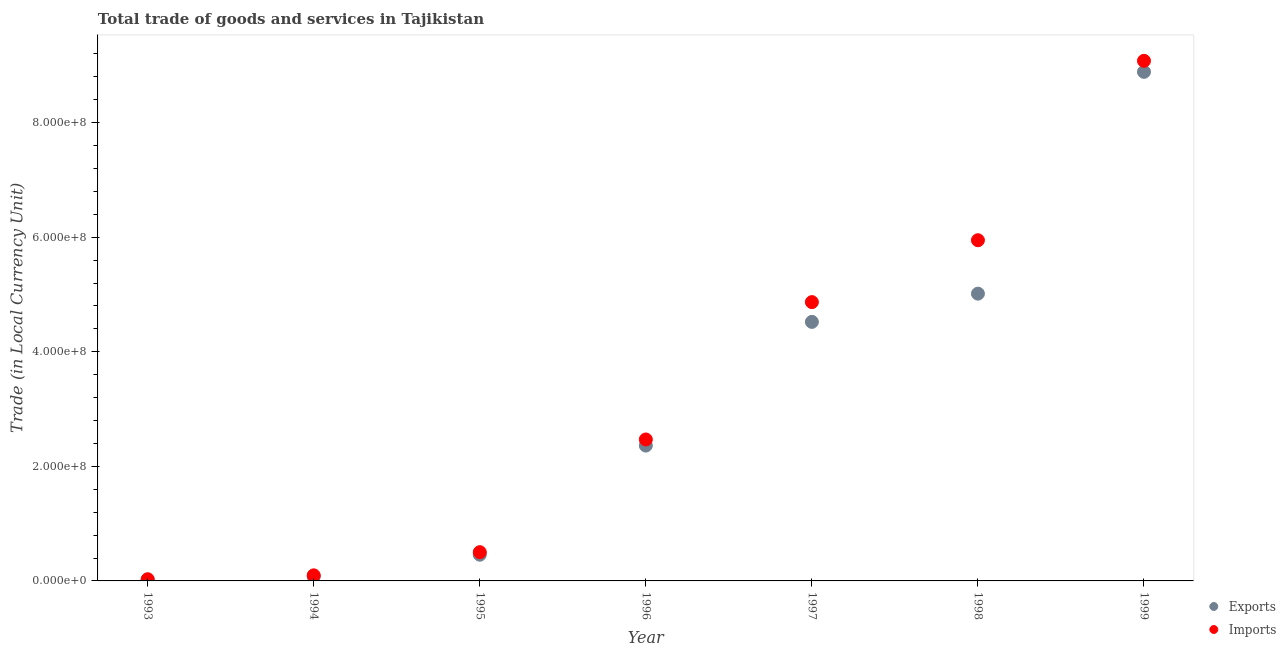How many different coloured dotlines are there?
Offer a terse response. 2. What is the imports of goods and services in 1994?
Offer a terse response. 9.76e+06. Across all years, what is the maximum imports of goods and services?
Your answer should be very brief. 9.08e+08. Across all years, what is the minimum export of goods and services?
Offer a terse response. 2.02e+06. In which year was the imports of goods and services maximum?
Make the answer very short. 1999. What is the total imports of goods and services in the graph?
Give a very brief answer. 2.30e+09. What is the difference between the imports of goods and services in 1995 and that in 1999?
Provide a succinct answer. -8.58e+08. What is the difference between the export of goods and services in 1994 and the imports of goods and services in 1995?
Your response must be concise. -4.25e+07. What is the average imports of goods and services per year?
Provide a succinct answer. 3.28e+08. In the year 1996, what is the difference between the export of goods and services and imports of goods and services?
Ensure brevity in your answer.  -1.07e+07. In how many years, is the imports of goods and services greater than 600000000 LCU?
Offer a very short reply. 1. What is the ratio of the imports of goods and services in 1996 to that in 1997?
Keep it short and to the point. 0.51. Is the export of goods and services in 1997 less than that in 1999?
Give a very brief answer. Yes. What is the difference between the highest and the second highest imports of goods and services?
Your response must be concise. 3.13e+08. What is the difference between the highest and the lowest imports of goods and services?
Keep it short and to the point. 9.05e+08. In how many years, is the export of goods and services greater than the average export of goods and services taken over all years?
Make the answer very short. 3. Does the export of goods and services monotonically increase over the years?
Offer a terse response. Yes. Is the imports of goods and services strictly less than the export of goods and services over the years?
Provide a short and direct response. No. How many dotlines are there?
Keep it short and to the point. 2. How many years are there in the graph?
Ensure brevity in your answer.  7. What is the difference between two consecutive major ticks on the Y-axis?
Keep it short and to the point. 2.00e+08. Are the values on the major ticks of Y-axis written in scientific E-notation?
Provide a short and direct response. Yes. Does the graph contain any zero values?
Offer a terse response. No. How are the legend labels stacked?
Your answer should be compact. Vertical. What is the title of the graph?
Your answer should be very brief. Total trade of goods and services in Tajikistan. What is the label or title of the X-axis?
Your answer should be compact. Year. What is the label or title of the Y-axis?
Keep it short and to the point. Trade (in Local Currency Unit). What is the Trade (in Local Currency Unit) in Exports in 1993?
Your response must be concise. 2.02e+06. What is the Trade (in Local Currency Unit) of Imports in 1993?
Your answer should be very brief. 2.94e+06. What is the Trade (in Local Currency Unit) in Exports in 1994?
Offer a very short reply. 7.69e+06. What is the Trade (in Local Currency Unit) of Imports in 1994?
Keep it short and to the point. 9.76e+06. What is the Trade (in Local Currency Unit) in Exports in 1995?
Provide a succinct answer. 4.58e+07. What is the Trade (in Local Currency Unit) in Imports in 1995?
Offer a terse response. 5.02e+07. What is the Trade (in Local Currency Unit) of Exports in 1996?
Your answer should be compact. 2.36e+08. What is the Trade (in Local Currency Unit) of Imports in 1996?
Keep it short and to the point. 2.47e+08. What is the Trade (in Local Currency Unit) in Exports in 1997?
Ensure brevity in your answer.  4.52e+08. What is the Trade (in Local Currency Unit) of Imports in 1997?
Provide a succinct answer. 4.87e+08. What is the Trade (in Local Currency Unit) in Exports in 1998?
Provide a succinct answer. 5.01e+08. What is the Trade (in Local Currency Unit) in Imports in 1998?
Provide a succinct answer. 5.95e+08. What is the Trade (in Local Currency Unit) of Exports in 1999?
Your answer should be compact. 8.89e+08. What is the Trade (in Local Currency Unit) in Imports in 1999?
Provide a short and direct response. 9.08e+08. Across all years, what is the maximum Trade (in Local Currency Unit) in Exports?
Give a very brief answer. 8.89e+08. Across all years, what is the maximum Trade (in Local Currency Unit) of Imports?
Provide a succinct answer. 9.08e+08. Across all years, what is the minimum Trade (in Local Currency Unit) of Exports?
Your response must be concise. 2.02e+06. Across all years, what is the minimum Trade (in Local Currency Unit) in Imports?
Give a very brief answer. 2.94e+06. What is the total Trade (in Local Currency Unit) in Exports in the graph?
Make the answer very short. 2.13e+09. What is the total Trade (in Local Currency Unit) in Imports in the graph?
Your response must be concise. 2.30e+09. What is the difference between the Trade (in Local Currency Unit) of Exports in 1993 and that in 1994?
Give a very brief answer. -5.67e+06. What is the difference between the Trade (in Local Currency Unit) in Imports in 1993 and that in 1994?
Your answer should be very brief. -6.81e+06. What is the difference between the Trade (in Local Currency Unit) in Exports in 1993 and that in 1995?
Your response must be concise. -4.38e+07. What is the difference between the Trade (in Local Currency Unit) in Imports in 1993 and that in 1995?
Give a very brief answer. -4.73e+07. What is the difference between the Trade (in Local Currency Unit) of Exports in 1993 and that in 1996?
Offer a terse response. -2.34e+08. What is the difference between the Trade (in Local Currency Unit) in Imports in 1993 and that in 1996?
Ensure brevity in your answer.  -2.44e+08. What is the difference between the Trade (in Local Currency Unit) in Exports in 1993 and that in 1997?
Provide a short and direct response. -4.50e+08. What is the difference between the Trade (in Local Currency Unit) of Imports in 1993 and that in 1997?
Your answer should be compact. -4.84e+08. What is the difference between the Trade (in Local Currency Unit) in Exports in 1993 and that in 1998?
Keep it short and to the point. -4.99e+08. What is the difference between the Trade (in Local Currency Unit) of Imports in 1993 and that in 1998?
Provide a succinct answer. -5.92e+08. What is the difference between the Trade (in Local Currency Unit) in Exports in 1993 and that in 1999?
Your answer should be very brief. -8.87e+08. What is the difference between the Trade (in Local Currency Unit) of Imports in 1993 and that in 1999?
Your answer should be very brief. -9.05e+08. What is the difference between the Trade (in Local Currency Unit) of Exports in 1994 and that in 1995?
Give a very brief answer. -3.81e+07. What is the difference between the Trade (in Local Currency Unit) of Imports in 1994 and that in 1995?
Your answer should be very brief. -4.05e+07. What is the difference between the Trade (in Local Currency Unit) of Exports in 1994 and that in 1996?
Provide a succinct answer. -2.29e+08. What is the difference between the Trade (in Local Currency Unit) of Imports in 1994 and that in 1996?
Your answer should be very brief. -2.37e+08. What is the difference between the Trade (in Local Currency Unit) in Exports in 1994 and that in 1997?
Offer a very short reply. -4.45e+08. What is the difference between the Trade (in Local Currency Unit) of Imports in 1994 and that in 1997?
Your answer should be compact. -4.77e+08. What is the difference between the Trade (in Local Currency Unit) of Exports in 1994 and that in 1998?
Offer a terse response. -4.94e+08. What is the difference between the Trade (in Local Currency Unit) in Imports in 1994 and that in 1998?
Your answer should be compact. -5.85e+08. What is the difference between the Trade (in Local Currency Unit) of Exports in 1994 and that in 1999?
Your answer should be compact. -8.81e+08. What is the difference between the Trade (in Local Currency Unit) in Imports in 1994 and that in 1999?
Give a very brief answer. -8.98e+08. What is the difference between the Trade (in Local Currency Unit) of Exports in 1995 and that in 1996?
Ensure brevity in your answer.  -1.90e+08. What is the difference between the Trade (in Local Currency Unit) of Imports in 1995 and that in 1996?
Make the answer very short. -1.97e+08. What is the difference between the Trade (in Local Currency Unit) in Exports in 1995 and that in 1997?
Keep it short and to the point. -4.06e+08. What is the difference between the Trade (in Local Currency Unit) of Imports in 1995 and that in 1997?
Your answer should be compact. -4.37e+08. What is the difference between the Trade (in Local Currency Unit) of Exports in 1995 and that in 1998?
Offer a terse response. -4.56e+08. What is the difference between the Trade (in Local Currency Unit) of Imports in 1995 and that in 1998?
Your response must be concise. -5.45e+08. What is the difference between the Trade (in Local Currency Unit) in Exports in 1995 and that in 1999?
Provide a succinct answer. -8.43e+08. What is the difference between the Trade (in Local Currency Unit) in Imports in 1995 and that in 1999?
Your answer should be very brief. -8.58e+08. What is the difference between the Trade (in Local Currency Unit) of Exports in 1996 and that in 1997?
Make the answer very short. -2.16e+08. What is the difference between the Trade (in Local Currency Unit) in Imports in 1996 and that in 1997?
Offer a very short reply. -2.40e+08. What is the difference between the Trade (in Local Currency Unit) in Exports in 1996 and that in 1998?
Provide a short and direct response. -2.65e+08. What is the difference between the Trade (in Local Currency Unit) of Imports in 1996 and that in 1998?
Ensure brevity in your answer.  -3.48e+08. What is the difference between the Trade (in Local Currency Unit) of Exports in 1996 and that in 1999?
Offer a very short reply. -6.52e+08. What is the difference between the Trade (in Local Currency Unit) of Imports in 1996 and that in 1999?
Ensure brevity in your answer.  -6.61e+08. What is the difference between the Trade (in Local Currency Unit) of Exports in 1997 and that in 1998?
Give a very brief answer. -4.93e+07. What is the difference between the Trade (in Local Currency Unit) of Imports in 1997 and that in 1998?
Your answer should be very brief. -1.08e+08. What is the difference between the Trade (in Local Currency Unit) in Exports in 1997 and that in 1999?
Keep it short and to the point. -4.36e+08. What is the difference between the Trade (in Local Currency Unit) in Imports in 1997 and that in 1999?
Ensure brevity in your answer.  -4.21e+08. What is the difference between the Trade (in Local Currency Unit) of Exports in 1998 and that in 1999?
Provide a short and direct response. -3.87e+08. What is the difference between the Trade (in Local Currency Unit) in Imports in 1998 and that in 1999?
Ensure brevity in your answer.  -3.13e+08. What is the difference between the Trade (in Local Currency Unit) in Exports in 1993 and the Trade (in Local Currency Unit) in Imports in 1994?
Your answer should be very brief. -7.74e+06. What is the difference between the Trade (in Local Currency Unit) of Exports in 1993 and the Trade (in Local Currency Unit) of Imports in 1995?
Keep it short and to the point. -4.82e+07. What is the difference between the Trade (in Local Currency Unit) in Exports in 1993 and the Trade (in Local Currency Unit) in Imports in 1996?
Keep it short and to the point. -2.45e+08. What is the difference between the Trade (in Local Currency Unit) in Exports in 1993 and the Trade (in Local Currency Unit) in Imports in 1997?
Your answer should be compact. -4.85e+08. What is the difference between the Trade (in Local Currency Unit) in Exports in 1993 and the Trade (in Local Currency Unit) in Imports in 1998?
Your response must be concise. -5.93e+08. What is the difference between the Trade (in Local Currency Unit) in Exports in 1993 and the Trade (in Local Currency Unit) in Imports in 1999?
Provide a succinct answer. -9.06e+08. What is the difference between the Trade (in Local Currency Unit) in Exports in 1994 and the Trade (in Local Currency Unit) in Imports in 1995?
Your response must be concise. -4.25e+07. What is the difference between the Trade (in Local Currency Unit) in Exports in 1994 and the Trade (in Local Currency Unit) in Imports in 1996?
Your answer should be compact. -2.39e+08. What is the difference between the Trade (in Local Currency Unit) in Exports in 1994 and the Trade (in Local Currency Unit) in Imports in 1997?
Offer a terse response. -4.79e+08. What is the difference between the Trade (in Local Currency Unit) in Exports in 1994 and the Trade (in Local Currency Unit) in Imports in 1998?
Give a very brief answer. -5.87e+08. What is the difference between the Trade (in Local Currency Unit) in Exports in 1994 and the Trade (in Local Currency Unit) in Imports in 1999?
Give a very brief answer. -9.00e+08. What is the difference between the Trade (in Local Currency Unit) in Exports in 1995 and the Trade (in Local Currency Unit) in Imports in 1996?
Provide a succinct answer. -2.01e+08. What is the difference between the Trade (in Local Currency Unit) in Exports in 1995 and the Trade (in Local Currency Unit) in Imports in 1997?
Provide a short and direct response. -4.41e+08. What is the difference between the Trade (in Local Currency Unit) in Exports in 1995 and the Trade (in Local Currency Unit) in Imports in 1998?
Offer a very short reply. -5.49e+08. What is the difference between the Trade (in Local Currency Unit) in Exports in 1995 and the Trade (in Local Currency Unit) in Imports in 1999?
Your answer should be very brief. -8.62e+08. What is the difference between the Trade (in Local Currency Unit) in Exports in 1996 and the Trade (in Local Currency Unit) in Imports in 1997?
Make the answer very short. -2.50e+08. What is the difference between the Trade (in Local Currency Unit) of Exports in 1996 and the Trade (in Local Currency Unit) of Imports in 1998?
Make the answer very short. -3.58e+08. What is the difference between the Trade (in Local Currency Unit) in Exports in 1996 and the Trade (in Local Currency Unit) in Imports in 1999?
Offer a very short reply. -6.72e+08. What is the difference between the Trade (in Local Currency Unit) of Exports in 1997 and the Trade (in Local Currency Unit) of Imports in 1998?
Offer a terse response. -1.43e+08. What is the difference between the Trade (in Local Currency Unit) of Exports in 1997 and the Trade (in Local Currency Unit) of Imports in 1999?
Provide a succinct answer. -4.56e+08. What is the difference between the Trade (in Local Currency Unit) in Exports in 1998 and the Trade (in Local Currency Unit) in Imports in 1999?
Make the answer very short. -4.06e+08. What is the average Trade (in Local Currency Unit) of Exports per year?
Provide a short and direct response. 3.05e+08. What is the average Trade (in Local Currency Unit) of Imports per year?
Give a very brief answer. 3.28e+08. In the year 1993, what is the difference between the Trade (in Local Currency Unit) in Exports and Trade (in Local Currency Unit) in Imports?
Provide a short and direct response. -9.25e+05. In the year 1994, what is the difference between the Trade (in Local Currency Unit) of Exports and Trade (in Local Currency Unit) of Imports?
Make the answer very short. -2.07e+06. In the year 1995, what is the difference between the Trade (in Local Currency Unit) in Exports and Trade (in Local Currency Unit) in Imports?
Your answer should be compact. -4.43e+06. In the year 1996, what is the difference between the Trade (in Local Currency Unit) of Exports and Trade (in Local Currency Unit) of Imports?
Ensure brevity in your answer.  -1.07e+07. In the year 1997, what is the difference between the Trade (in Local Currency Unit) of Exports and Trade (in Local Currency Unit) of Imports?
Your answer should be compact. -3.45e+07. In the year 1998, what is the difference between the Trade (in Local Currency Unit) in Exports and Trade (in Local Currency Unit) in Imports?
Provide a short and direct response. -9.32e+07. In the year 1999, what is the difference between the Trade (in Local Currency Unit) in Exports and Trade (in Local Currency Unit) in Imports?
Ensure brevity in your answer.  -1.93e+07. What is the ratio of the Trade (in Local Currency Unit) in Exports in 1993 to that in 1994?
Provide a succinct answer. 0.26. What is the ratio of the Trade (in Local Currency Unit) in Imports in 1993 to that in 1994?
Your answer should be compact. 0.3. What is the ratio of the Trade (in Local Currency Unit) of Exports in 1993 to that in 1995?
Make the answer very short. 0.04. What is the ratio of the Trade (in Local Currency Unit) in Imports in 1993 to that in 1995?
Your response must be concise. 0.06. What is the ratio of the Trade (in Local Currency Unit) in Exports in 1993 to that in 1996?
Provide a short and direct response. 0.01. What is the ratio of the Trade (in Local Currency Unit) in Imports in 1993 to that in 1996?
Offer a terse response. 0.01. What is the ratio of the Trade (in Local Currency Unit) in Exports in 1993 to that in 1997?
Give a very brief answer. 0. What is the ratio of the Trade (in Local Currency Unit) of Imports in 1993 to that in 1997?
Provide a succinct answer. 0.01. What is the ratio of the Trade (in Local Currency Unit) in Exports in 1993 to that in 1998?
Provide a short and direct response. 0. What is the ratio of the Trade (in Local Currency Unit) of Imports in 1993 to that in 1998?
Make the answer very short. 0.01. What is the ratio of the Trade (in Local Currency Unit) of Exports in 1993 to that in 1999?
Offer a very short reply. 0. What is the ratio of the Trade (in Local Currency Unit) of Imports in 1993 to that in 1999?
Give a very brief answer. 0. What is the ratio of the Trade (in Local Currency Unit) of Exports in 1994 to that in 1995?
Provide a succinct answer. 0.17. What is the ratio of the Trade (in Local Currency Unit) of Imports in 1994 to that in 1995?
Provide a succinct answer. 0.19. What is the ratio of the Trade (in Local Currency Unit) in Exports in 1994 to that in 1996?
Offer a very short reply. 0.03. What is the ratio of the Trade (in Local Currency Unit) of Imports in 1994 to that in 1996?
Make the answer very short. 0.04. What is the ratio of the Trade (in Local Currency Unit) in Exports in 1994 to that in 1997?
Give a very brief answer. 0.02. What is the ratio of the Trade (in Local Currency Unit) of Imports in 1994 to that in 1997?
Make the answer very short. 0.02. What is the ratio of the Trade (in Local Currency Unit) of Exports in 1994 to that in 1998?
Your answer should be very brief. 0.02. What is the ratio of the Trade (in Local Currency Unit) in Imports in 1994 to that in 1998?
Provide a succinct answer. 0.02. What is the ratio of the Trade (in Local Currency Unit) in Exports in 1994 to that in 1999?
Your response must be concise. 0.01. What is the ratio of the Trade (in Local Currency Unit) in Imports in 1994 to that in 1999?
Your answer should be compact. 0.01. What is the ratio of the Trade (in Local Currency Unit) in Exports in 1995 to that in 1996?
Give a very brief answer. 0.19. What is the ratio of the Trade (in Local Currency Unit) of Imports in 1995 to that in 1996?
Your answer should be compact. 0.2. What is the ratio of the Trade (in Local Currency Unit) in Exports in 1995 to that in 1997?
Provide a short and direct response. 0.1. What is the ratio of the Trade (in Local Currency Unit) in Imports in 1995 to that in 1997?
Ensure brevity in your answer.  0.1. What is the ratio of the Trade (in Local Currency Unit) in Exports in 1995 to that in 1998?
Offer a terse response. 0.09. What is the ratio of the Trade (in Local Currency Unit) in Imports in 1995 to that in 1998?
Keep it short and to the point. 0.08. What is the ratio of the Trade (in Local Currency Unit) in Exports in 1995 to that in 1999?
Keep it short and to the point. 0.05. What is the ratio of the Trade (in Local Currency Unit) in Imports in 1995 to that in 1999?
Ensure brevity in your answer.  0.06. What is the ratio of the Trade (in Local Currency Unit) in Exports in 1996 to that in 1997?
Your answer should be very brief. 0.52. What is the ratio of the Trade (in Local Currency Unit) of Imports in 1996 to that in 1997?
Make the answer very short. 0.51. What is the ratio of the Trade (in Local Currency Unit) in Exports in 1996 to that in 1998?
Provide a succinct answer. 0.47. What is the ratio of the Trade (in Local Currency Unit) in Imports in 1996 to that in 1998?
Keep it short and to the point. 0.42. What is the ratio of the Trade (in Local Currency Unit) of Exports in 1996 to that in 1999?
Offer a terse response. 0.27. What is the ratio of the Trade (in Local Currency Unit) of Imports in 1996 to that in 1999?
Keep it short and to the point. 0.27. What is the ratio of the Trade (in Local Currency Unit) of Exports in 1997 to that in 1998?
Ensure brevity in your answer.  0.9. What is the ratio of the Trade (in Local Currency Unit) of Imports in 1997 to that in 1998?
Provide a succinct answer. 0.82. What is the ratio of the Trade (in Local Currency Unit) of Exports in 1997 to that in 1999?
Keep it short and to the point. 0.51. What is the ratio of the Trade (in Local Currency Unit) in Imports in 1997 to that in 1999?
Give a very brief answer. 0.54. What is the ratio of the Trade (in Local Currency Unit) in Exports in 1998 to that in 1999?
Keep it short and to the point. 0.56. What is the ratio of the Trade (in Local Currency Unit) in Imports in 1998 to that in 1999?
Your response must be concise. 0.66. What is the difference between the highest and the second highest Trade (in Local Currency Unit) of Exports?
Keep it short and to the point. 3.87e+08. What is the difference between the highest and the second highest Trade (in Local Currency Unit) in Imports?
Offer a very short reply. 3.13e+08. What is the difference between the highest and the lowest Trade (in Local Currency Unit) in Exports?
Ensure brevity in your answer.  8.87e+08. What is the difference between the highest and the lowest Trade (in Local Currency Unit) of Imports?
Your response must be concise. 9.05e+08. 